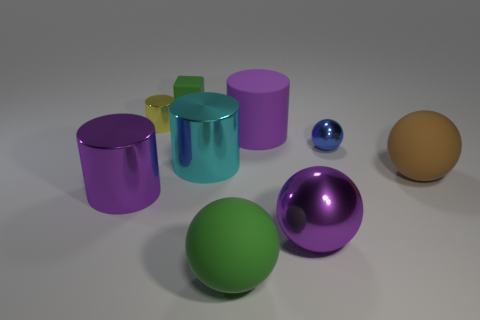Subtract all brown cubes. How many purple cylinders are left? 2 Subtract all big brown balls. How many balls are left? 3 Subtract all cyan cylinders. How many cylinders are left? 3 Subtract all blocks. How many objects are left? 8 Subtract 1 spheres. How many spheres are left? 3 Subtract all small blue balls. Subtract all yellow metal objects. How many objects are left? 7 Add 4 big matte things. How many big matte things are left? 7 Add 3 yellow cylinders. How many yellow cylinders exist? 4 Subtract 0 brown blocks. How many objects are left? 9 Subtract all yellow balls. Subtract all brown cylinders. How many balls are left? 4 